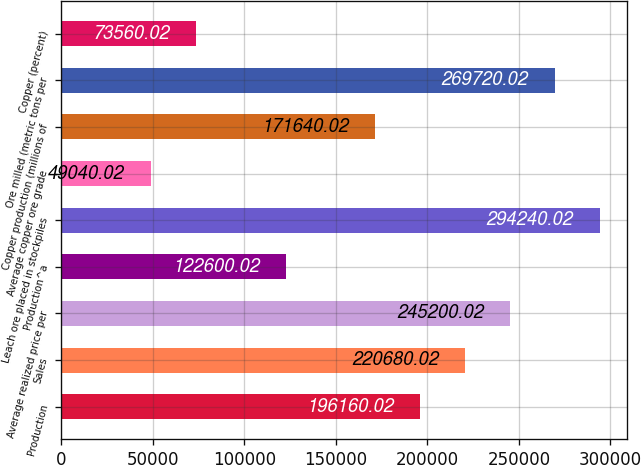Convert chart to OTSL. <chart><loc_0><loc_0><loc_500><loc_500><bar_chart><fcel>Production<fcel>Sales<fcel>Average realized price per<fcel>Production^a<fcel>Leach ore placed in stockpiles<fcel>Average copper ore grade<fcel>Copper production (millions of<fcel>Ore milled (metric tons per<fcel>Copper (percent)<nl><fcel>196160<fcel>220680<fcel>245200<fcel>122600<fcel>294240<fcel>49040<fcel>171640<fcel>269720<fcel>73560<nl></chart> 